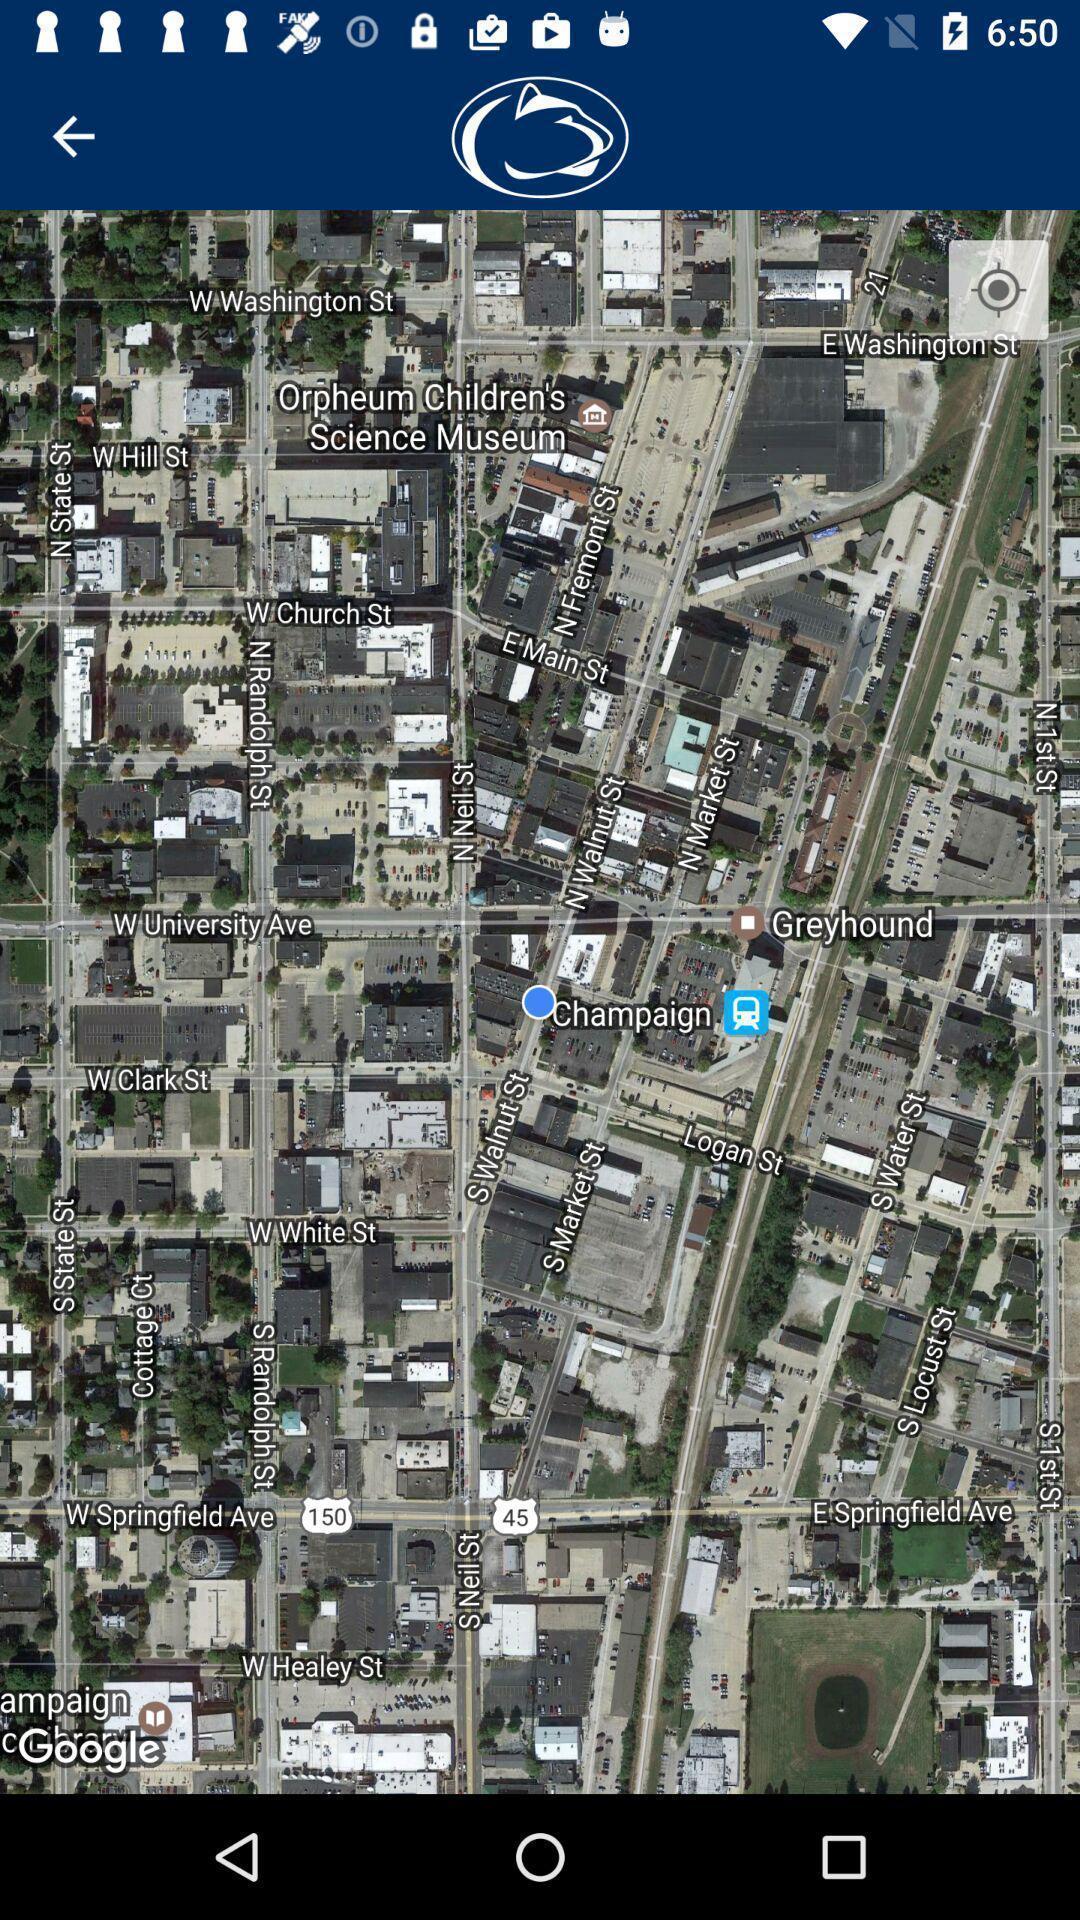Tell me what you see in this picture. Page showing the locations in maps. 